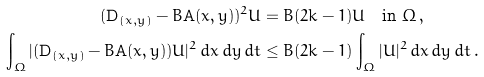Convert formula to latex. <formula><loc_0><loc_0><loc_500><loc_500>( \mathbf D _ { ( x , y ) } - B \mathbf A ( x , y ) ) ^ { 2 } U & = B ( 2 k - 1 ) U \quad \text {in} \ \Omega \, , \\ \int _ { \Omega } | ( \mathbf D _ { ( x , y ) } - B \mathbf A ( x , y ) ) U | ^ { 2 } \, d x \, d y \, d t & \leq B ( 2 k - 1 ) \int _ { \Omega } | U | ^ { 2 } \, d x \, d y \, d t \, .</formula> 